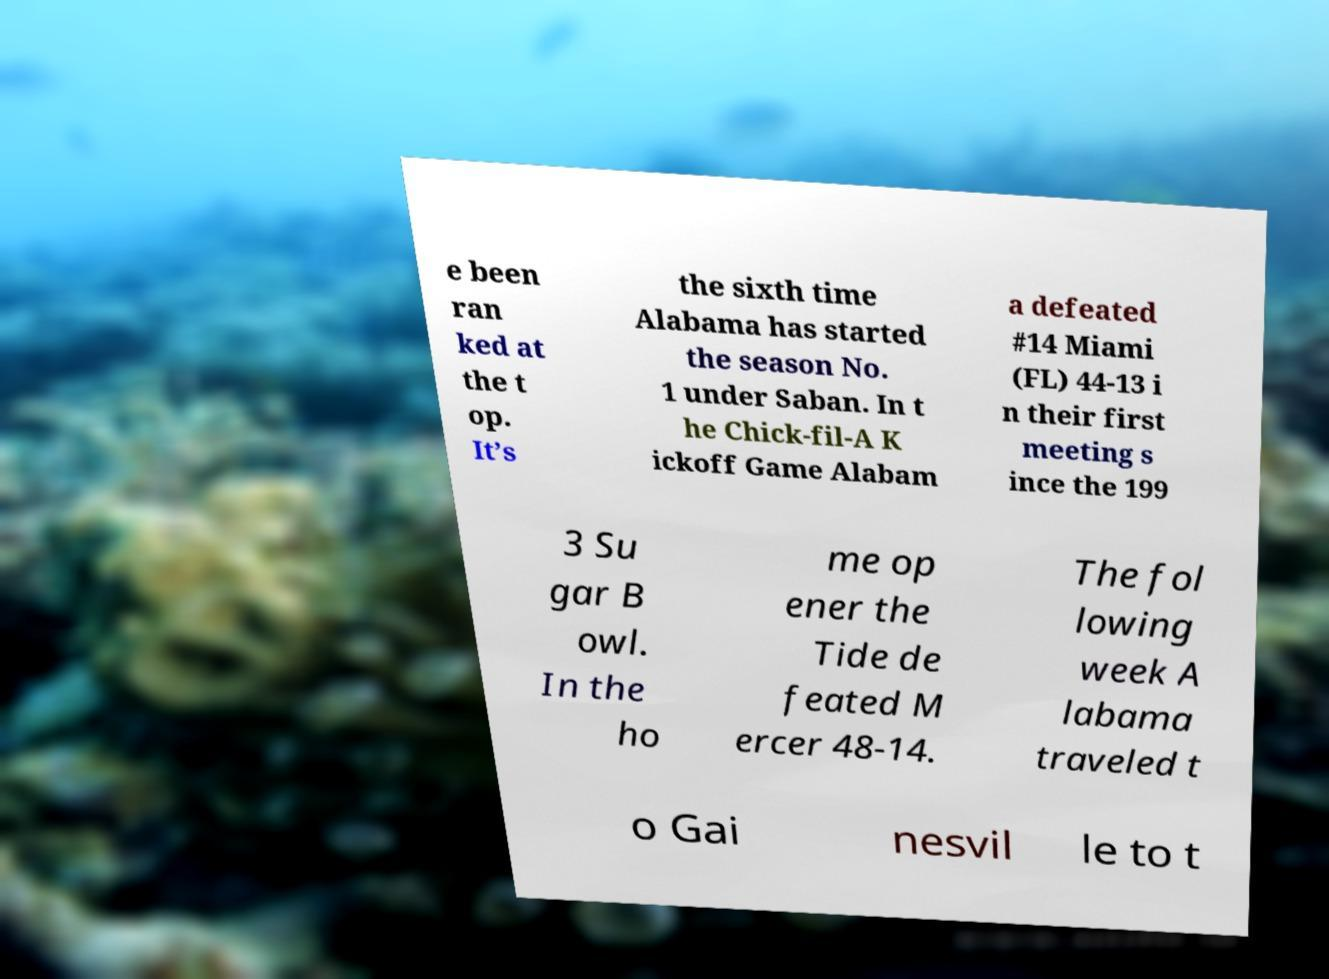There's text embedded in this image that I need extracted. Can you transcribe it verbatim? e been ran ked at the t op. It’s the sixth time Alabama has started the season No. 1 under Saban. In t he Chick-fil-A K ickoff Game Alabam a defeated #14 Miami (FL) 44-13 i n their first meeting s ince the 199 3 Su gar B owl. In the ho me op ener the Tide de feated M ercer 48-14. The fol lowing week A labama traveled t o Gai nesvil le to t 